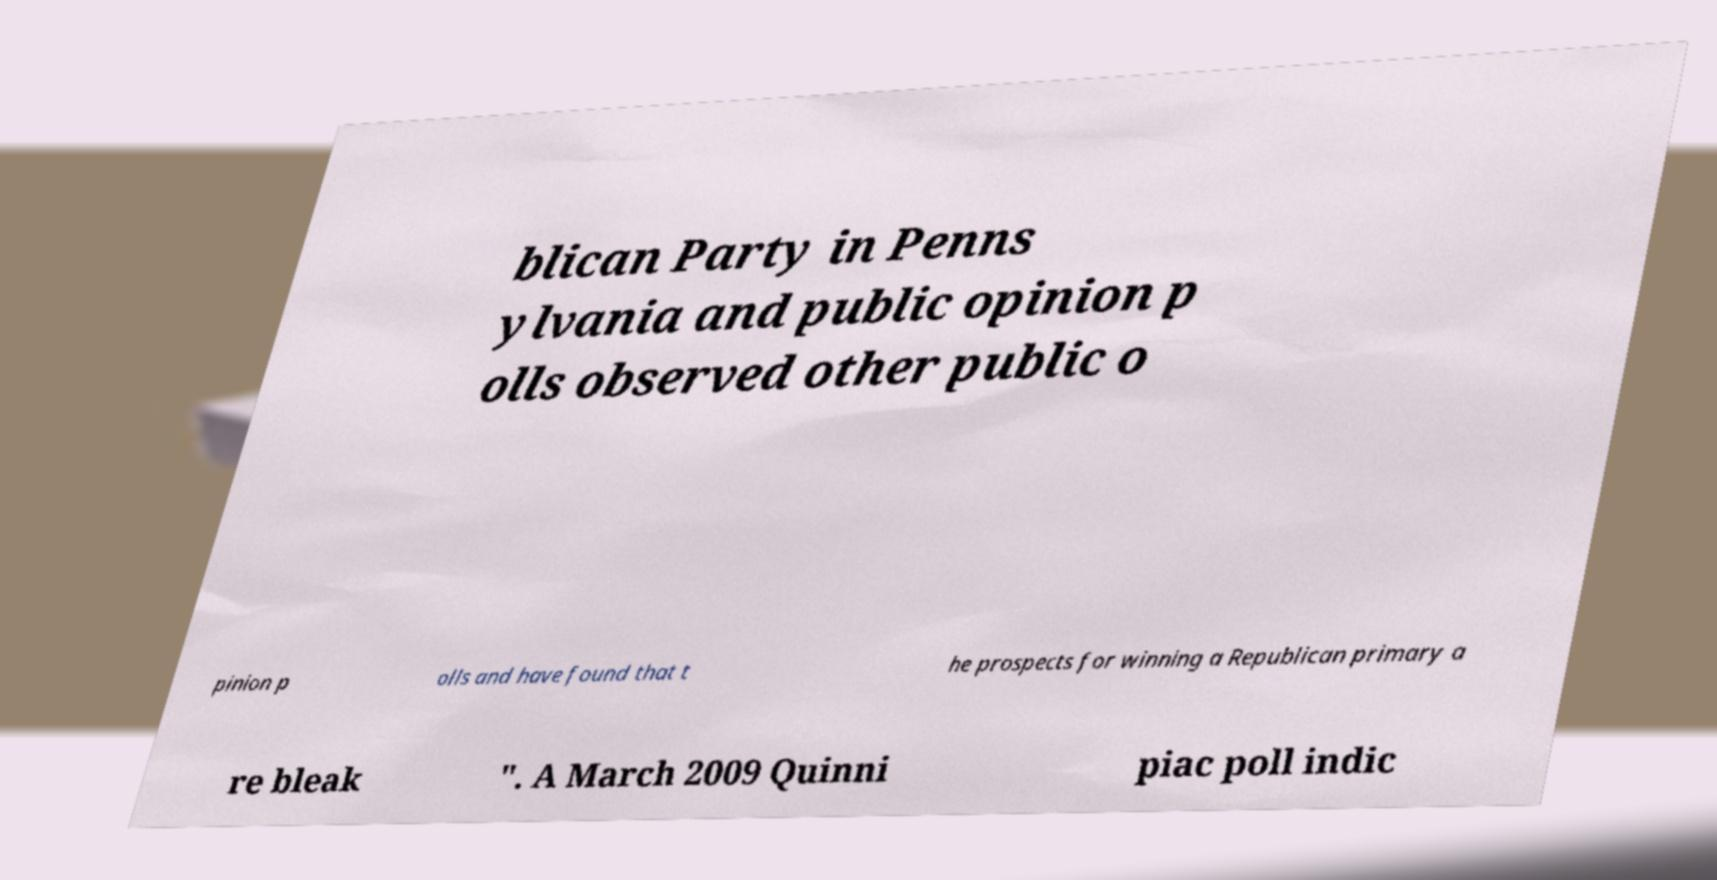Can you accurately transcribe the text from the provided image for me? blican Party in Penns ylvania and public opinion p olls observed other public o pinion p olls and have found that t he prospects for winning a Republican primary a re bleak ". A March 2009 Quinni piac poll indic 